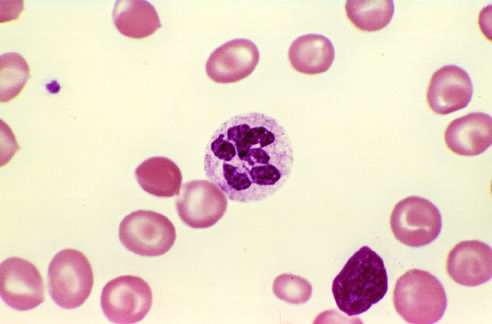does the pattern of staining of anti-centromere antibodies show a hyper-segmented neutrophil with a six-lobed nucleus?
Answer the question using a single word or phrase. No 